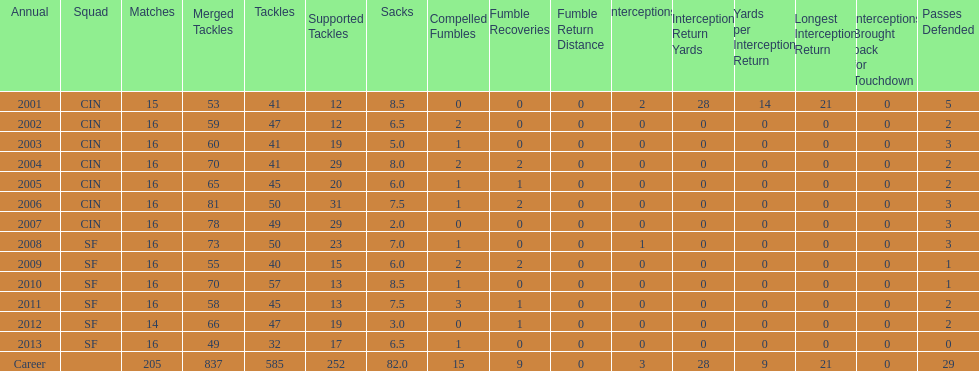How many sacks did this player have in his first five seasons? 34. 